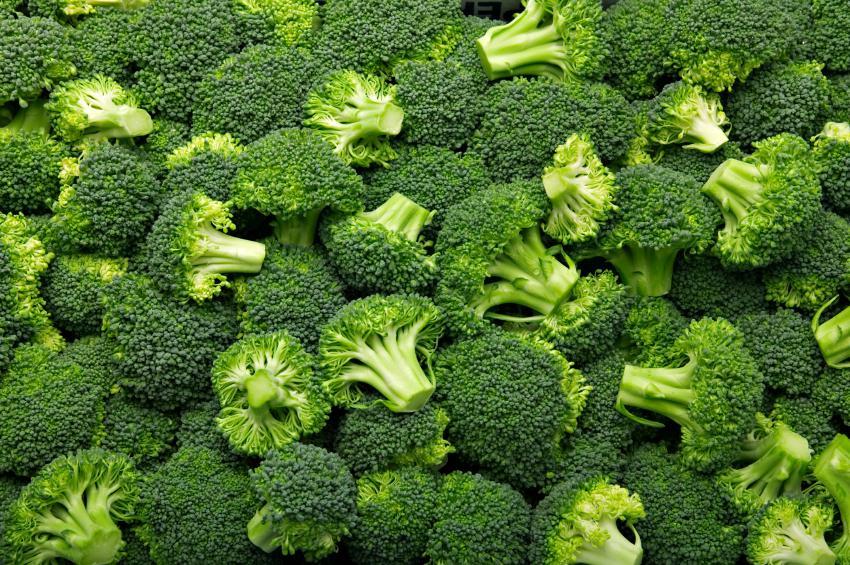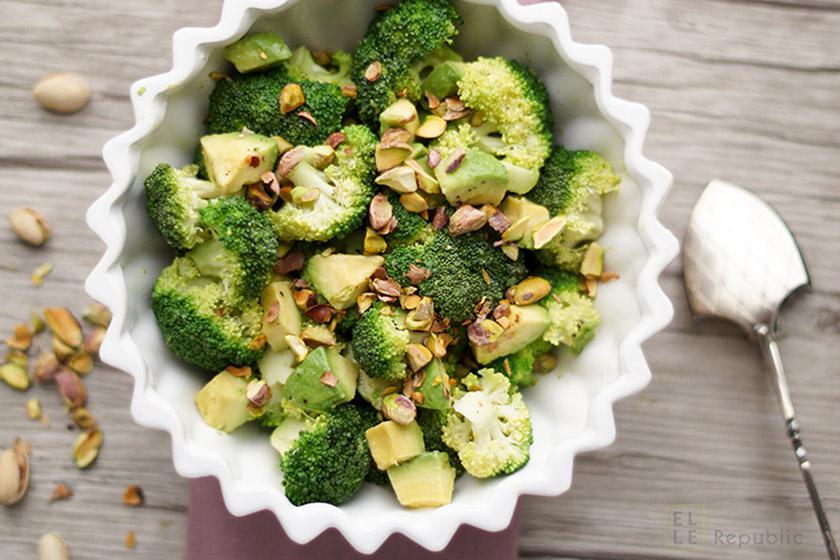The first image is the image on the left, the second image is the image on the right. Evaluate the accuracy of this statement regarding the images: "A bowl of just broccoli sits on a table with some broccoli pieces around it.". Is it true? Answer yes or no. No. The first image is the image on the left, the second image is the image on the right. Considering the images on both sides, is "There is exactly one bowl of broccoli." valid? Answer yes or no. Yes. 